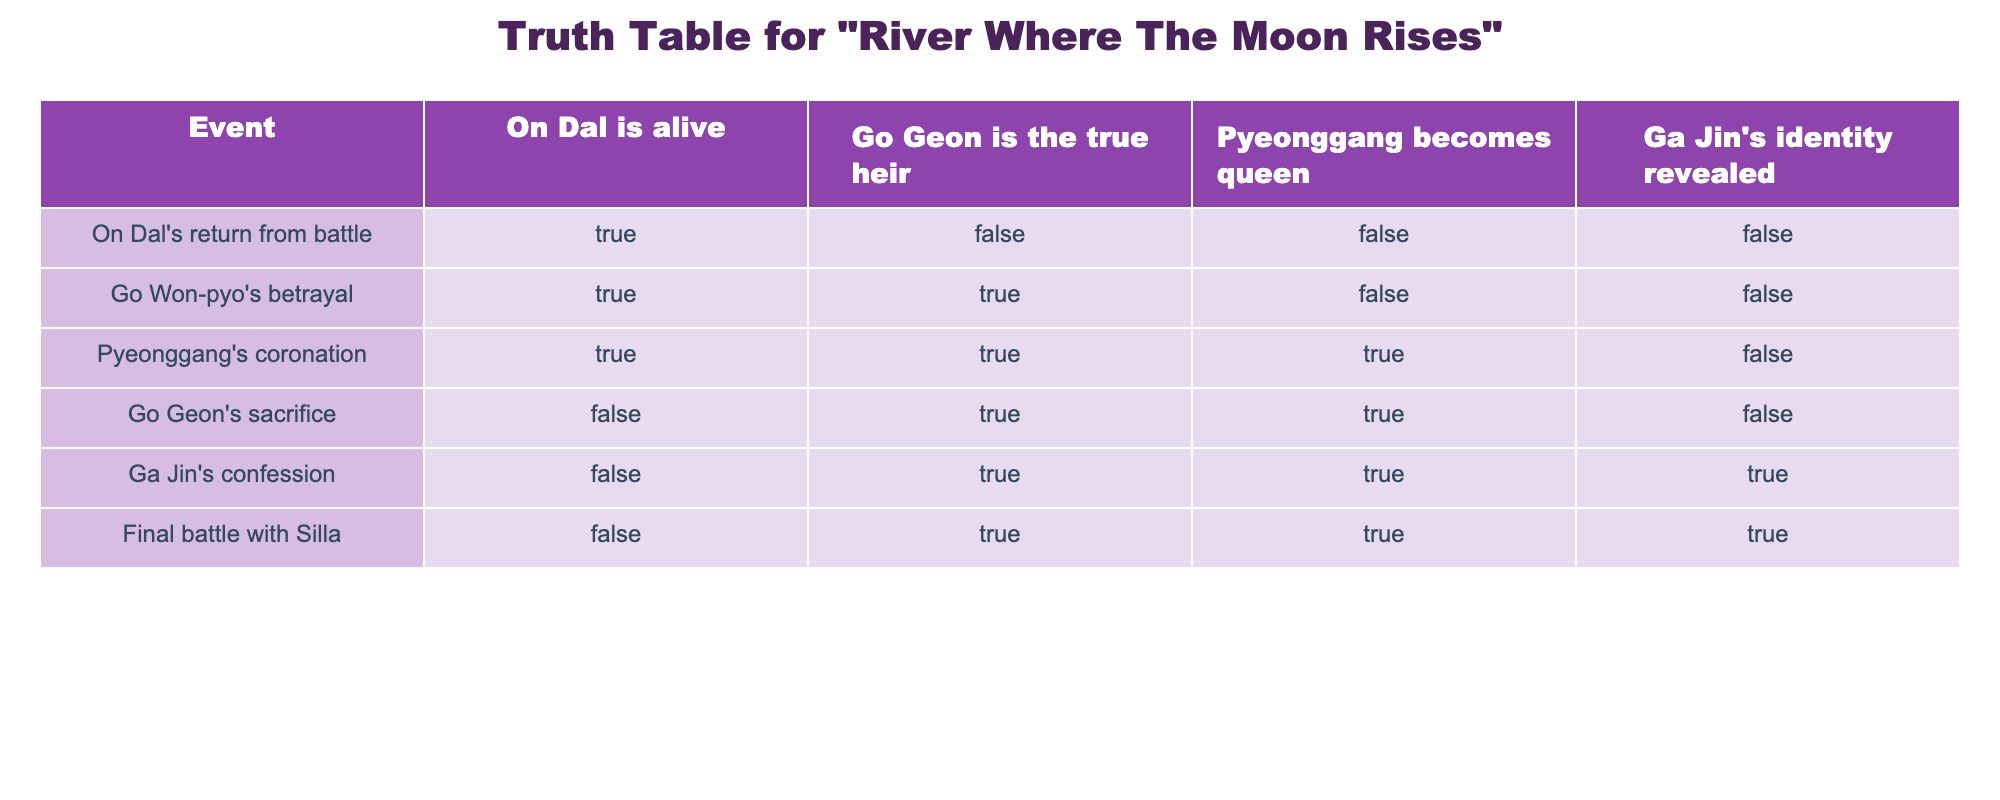What is the truth value for On Dal being alive when he returns from battle? According to the table, the entry for "On Dal's return from battle" shows TRUE under the "On Dal is alive" column.
Answer: TRUE Was Go Geon confirmed as the true heir after Go Won-pyo's betrayal? In the table, the row for "Go Won-pyo's betrayal" shows TRUE under the "Go Geon is the true heir" column.
Answer: TRUE What happens to Pyeonggang when Ga Jin's identity is revealed? Looking at the row for "Ga Jin's confession", it is indicated by TRUE under the "Pyeonggang becomes queen" column, which means her becoming queen occurred alongside this event.
Answer: TRUE How many events lead to Go Geon being identified as the true heir? By examining the columns where "Go Geon is the true heir" is marked TRUE, we find 4 events (Go Won-pyo's betrayal, Pyeonggang's coronation, Go Geon's sacrifice, Ga Jin's confession, and Final battle with Silla). Thus, 4 events support this outcome.
Answer: 4 Is there any instance where On Dal is alive and Ga Jin’s identity is revealed? Looking at the rows, On Dal is marked TRUE only for the event “On Dal's return from battle,” while Ga Jin's identity is revealed as TRUE only in the event “Ga Jin's confession.” No rows have both conditions as TRUE.
Answer: FALSE In the final battle with Silla, what are the truth values for all key plot twists? In the last row for "Final battle with Silla", the truths are: On Dal is alive: FALSE, Go Geon is the true heir: TRUE, Pyeonggang becomes queen: TRUE, Ga Jin's identity revealed: TRUE.
Answer: FALSE, TRUE, TRUE, TRUE What is the value of Pyeonggang becoming queen during Go Geon's sacrifice? Referring to the row for "Go Geon's sacrifice," Pyeonggang becoming queen shows TRUE, indicating that her ascension happened at this event.
Answer: TRUE How many events confirm that Ga Jin has revealed her identity? We can check the table for rows marked TRUE under “Ga Jin's identity revealed,” finding 3 events affirming this. They are: Ga Jin's confession and Final battle with Silla.
Answer: 3 What is the relationship between Go Geon's sacrifice and Pyeonggang becoming queen? The row for "Go Geon's sacrifice" indicates both events (Go Geon is the true heir is marked TRUE and Pyeonggang becoming queen is marked TRUE) occurred together, which highlights a direct relationship.
Answer: TRUE 